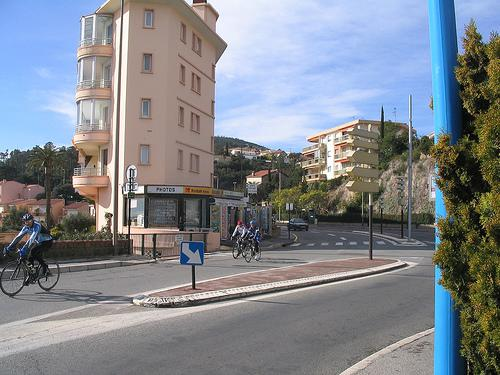Question: who are the people in the picture?
Choices:
A. Runners.
B. Baseball Players.
C. Football Players.
D. Bikers.
Answer with the letter. Answer: D Question: how many bikers are there?
Choices:
A. Two.
B. Three.
C. Four.
D. Five.
Answer with the letter. Answer: B Question: what is written on one of the shops?
Choices:
A. Flowers.
B. Books.
C. Thrift Store.
D. Photos.
Answer with the letter. Answer: D Question: what color are the bikers helmet?
Choices:
A. Silver and white.
B. Blue and red.
C. Blue and black.
D. Green and yellow.
Answer with the letter. Answer: B 